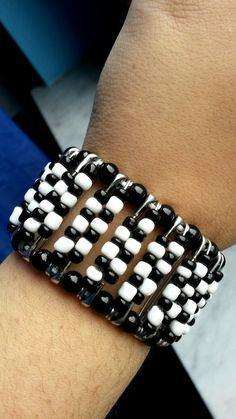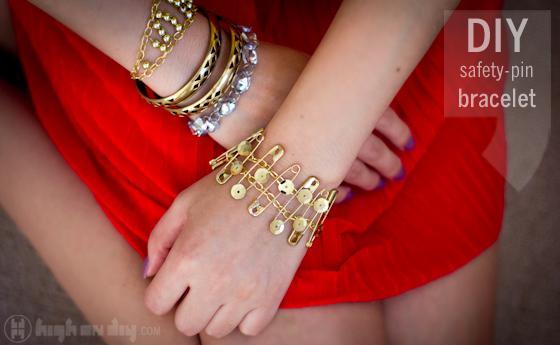The first image is the image on the left, the second image is the image on the right. Assess this claim about the two images: "One of the images shows both the legs and arms of a model.". Correct or not? Answer yes or no. Yes. 